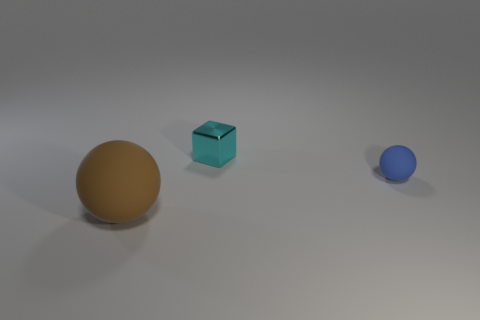Is there any other thing that is made of the same material as the small cube?
Keep it short and to the point. No. What is the ball that is behind the large thing made of?
Your answer should be very brief. Rubber. What is the shape of the rubber thing that is the same size as the cyan shiny cube?
Provide a succinct answer. Sphere. Are there any red metallic things that have the same shape as the big rubber object?
Give a very brief answer. No. Are the tiny cube and the ball that is behind the brown matte ball made of the same material?
Your answer should be compact. No. The ball that is right of the matte ball to the left of the tiny cyan metallic cube is made of what material?
Ensure brevity in your answer.  Rubber. Are there more large objects that are behind the small cyan block than blue matte things?
Provide a succinct answer. No. Are any large red rubber blocks visible?
Keep it short and to the point. No. What color is the matte sphere to the right of the big matte ball?
Offer a terse response. Blue. What is the material of the cyan block that is the same size as the blue thing?
Provide a short and direct response. Metal. 